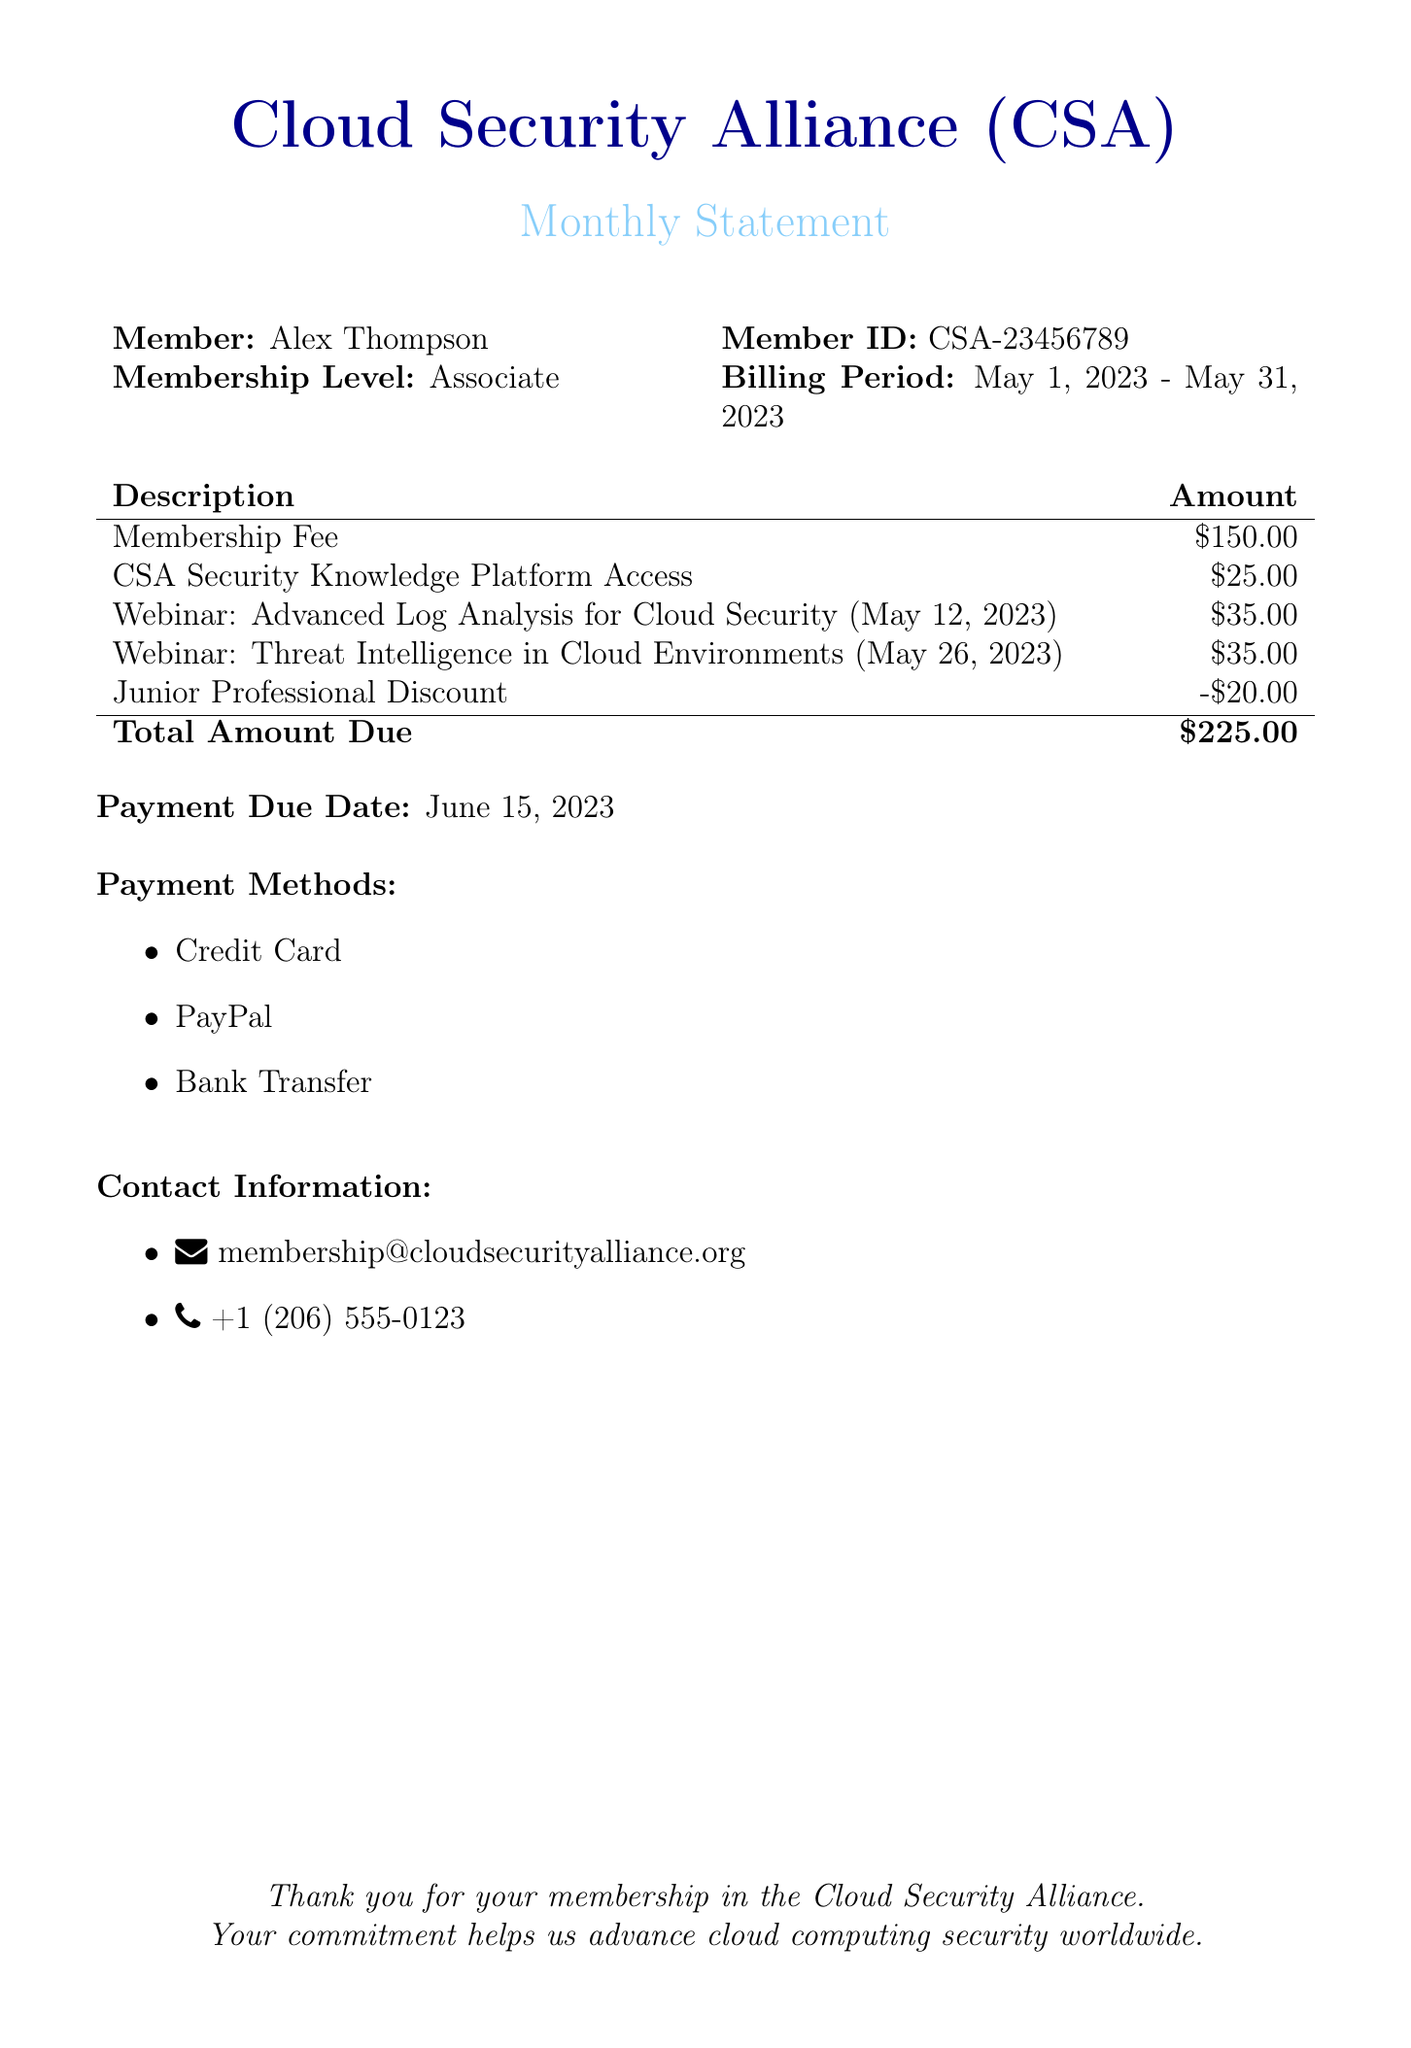What is the member's name? The member's name is listed near the top of the bill, identified as Alex Thompson.
Answer: Alex Thompson What is the billing period? The billing period specifies the time frame for which the membership fee and services are being billed. It is stated as May 1, 2023 - May 31, 2023.
Answer: May 1, 2023 - May 31, 2023 What is the total amount due? The total amount due is calculated by summing all applicable fees and discounts listed in the document. The final total is $225.00.
Answer: $225.00 What discount was applied to the membership fee? The document indicates a discount specifically for juniors, which is a subtraction from the total amount due.
Answer: -$20.00 How much does access to the CSA Security Knowledge Platform cost? This cost is detailed in the table of fees and specified as part of the membership services.
Answer: $25.00 When is the payment due date? The due date for payment is explicitly mentioned in the document to ensure timely payment of the billed amount.
Answer: June 15, 2023 What payment methods are accepted? The document lists various accepted payment methods, implying options for the member to settle their bill.
Answer: Credit Card, PayPal, Bank Transfer How many webinars are included in this month's statement? The number of webinars can be counted from the list of descriptions in the statement, along with their respective dates.
Answer: 2 